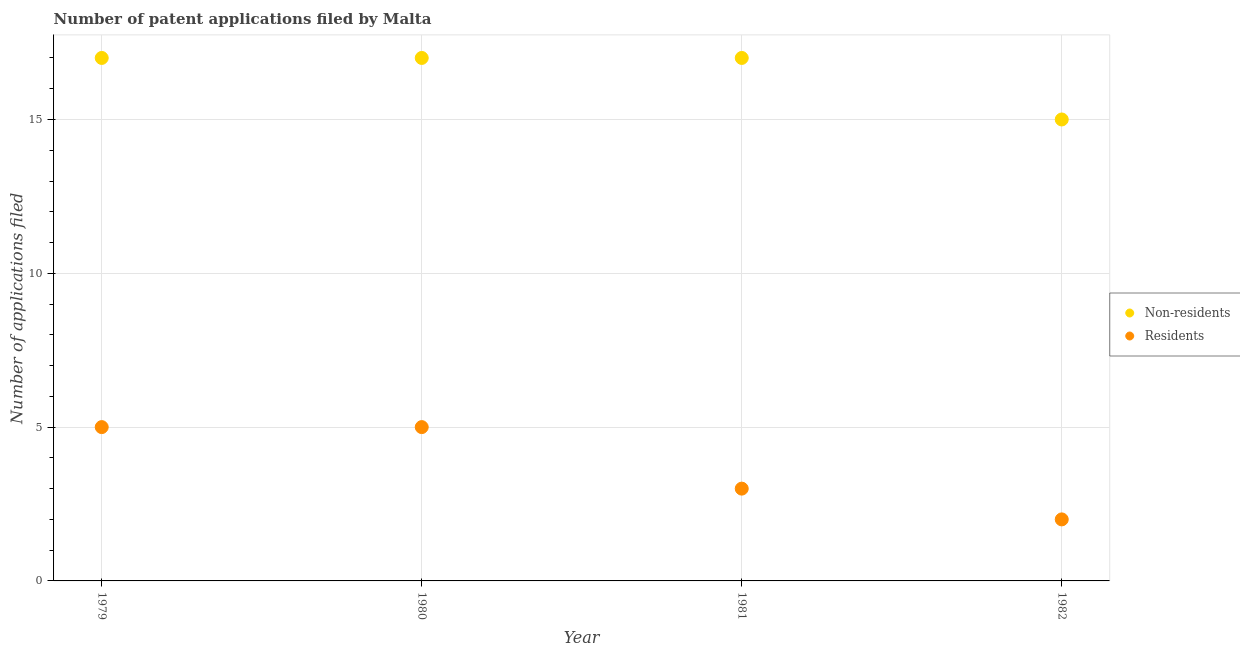How many different coloured dotlines are there?
Your answer should be very brief. 2. Is the number of dotlines equal to the number of legend labels?
Your response must be concise. Yes. What is the number of patent applications by non residents in 1979?
Provide a succinct answer. 17. Across all years, what is the maximum number of patent applications by non residents?
Provide a succinct answer. 17. Across all years, what is the minimum number of patent applications by non residents?
Keep it short and to the point. 15. In which year was the number of patent applications by non residents maximum?
Your answer should be compact. 1979. In which year was the number of patent applications by residents minimum?
Provide a succinct answer. 1982. What is the total number of patent applications by residents in the graph?
Provide a short and direct response. 15. What is the difference between the number of patent applications by non residents in 1979 and the number of patent applications by residents in 1981?
Your answer should be very brief. 14. What is the average number of patent applications by residents per year?
Ensure brevity in your answer.  3.75. In the year 1980, what is the difference between the number of patent applications by residents and number of patent applications by non residents?
Keep it short and to the point. -12. In how many years, is the number of patent applications by non residents greater than 13?
Make the answer very short. 4. Is the number of patent applications by residents in 1979 less than that in 1980?
Ensure brevity in your answer.  No. Is the difference between the number of patent applications by non residents in 1980 and 1981 greater than the difference between the number of patent applications by residents in 1980 and 1981?
Your answer should be compact. No. What is the difference between the highest and the lowest number of patent applications by residents?
Ensure brevity in your answer.  3. Is the sum of the number of patent applications by non residents in 1979 and 1982 greater than the maximum number of patent applications by residents across all years?
Offer a very short reply. Yes. Is the number of patent applications by residents strictly greater than the number of patent applications by non residents over the years?
Provide a succinct answer. No. How many years are there in the graph?
Keep it short and to the point. 4. Does the graph contain any zero values?
Provide a succinct answer. No. Where does the legend appear in the graph?
Make the answer very short. Center right. How many legend labels are there?
Offer a terse response. 2. What is the title of the graph?
Your response must be concise. Number of patent applications filed by Malta. Does "By country of origin" appear as one of the legend labels in the graph?
Offer a terse response. No. What is the label or title of the X-axis?
Ensure brevity in your answer.  Year. What is the label or title of the Y-axis?
Your answer should be compact. Number of applications filed. What is the Number of applications filed of Non-residents in 1979?
Make the answer very short. 17. What is the Number of applications filed of Residents in 1979?
Make the answer very short. 5. What is the Number of applications filed of Residents in 1980?
Provide a succinct answer. 5. What is the Number of applications filed of Non-residents in 1981?
Your response must be concise. 17. What is the Number of applications filed in Non-residents in 1982?
Ensure brevity in your answer.  15. What is the Number of applications filed in Residents in 1982?
Offer a very short reply. 2. Across all years, what is the maximum Number of applications filed in Non-residents?
Offer a terse response. 17. Across all years, what is the maximum Number of applications filed of Residents?
Make the answer very short. 5. Across all years, what is the minimum Number of applications filed of Residents?
Offer a very short reply. 2. What is the total Number of applications filed of Residents in the graph?
Keep it short and to the point. 15. What is the difference between the Number of applications filed of Residents in 1979 and that in 1980?
Provide a short and direct response. 0. What is the difference between the Number of applications filed of Non-residents in 1979 and that in 1981?
Your response must be concise. 0. What is the difference between the Number of applications filed of Residents in 1979 and that in 1982?
Provide a short and direct response. 3. What is the difference between the Number of applications filed of Non-residents in 1980 and that in 1981?
Provide a short and direct response. 0. What is the difference between the Number of applications filed of Residents in 1980 and that in 1981?
Provide a short and direct response. 2. What is the difference between the Number of applications filed in Residents in 1981 and that in 1982?
Your answer should be compact. 1. What is the difference between the Number of applications filed of Non-residents in 1979 and the Number of applications filed of Residents in 1980?
Your answer should be very brief. 12. What is the difference between the Number of applications filed in Non-residents in 1979 and the Number of applications filed in Residents in 1981?
Provide a succinct answer. 14. What is the difference between the Number of applications filed of Non-residents in 1980 and the Number of applications filed of Residents in 1981?
Ensure brevity in your answer.  14. What is the difference between the Number of applications filed in Non-residents in 1980 and the Number of applications filed in Residents in 1982?
Ensure brevity in your answer.  15. What is the average Number of applications filed of Residents per year?
Keep it short and to the point. 3.75. In the year 1979, what is the difference between the Number of applications filed in Non-residents and Number of applications filed in Residents?
Provide a succinct answer. 12. In the year 1982, what is the difference between the Number of applications filed of Non-residents and Number of applications filed of Residents?
Provide a succinct answer. 13. What is the ratio of the Number of applications filed of Non-residents in 1979 to that in 1980?
Provide a short and direct response. 1. What is the ratio of the Number of applications filed of Residents in 1979 to that in 1980?
Offer a very short reply. 1. What is the ratio of the Number of applications filed in Residents in 1979 to that in 1981?
Provide a short and direct response. 1.67. What is the ratio of the Number of applications filed in Non-residents in 1979 to that in 1982?
Your answer should be very brief. 1.13. What is the ratio of the Number of applications filed of Non-residents in 1980 to that in 1981?
Offer a very short reply. 1. What is the ratio of the Number of applications filed of Non-residents in 1980 to that in 1982?
Make the answer very short. 1.13. What is the ratio of the Number of applications filed in Residents in 1980 to that in 1982?
Offer a terse response. 2.5. What is the ratio of the Number of applications filed of Non-residents in 1981 to that in 1982?
Your answer should be very brief. 1.13. What is the difference between the highest and the lowest Number of applications filed of Residents?
Keep it short and to the point. 3. 